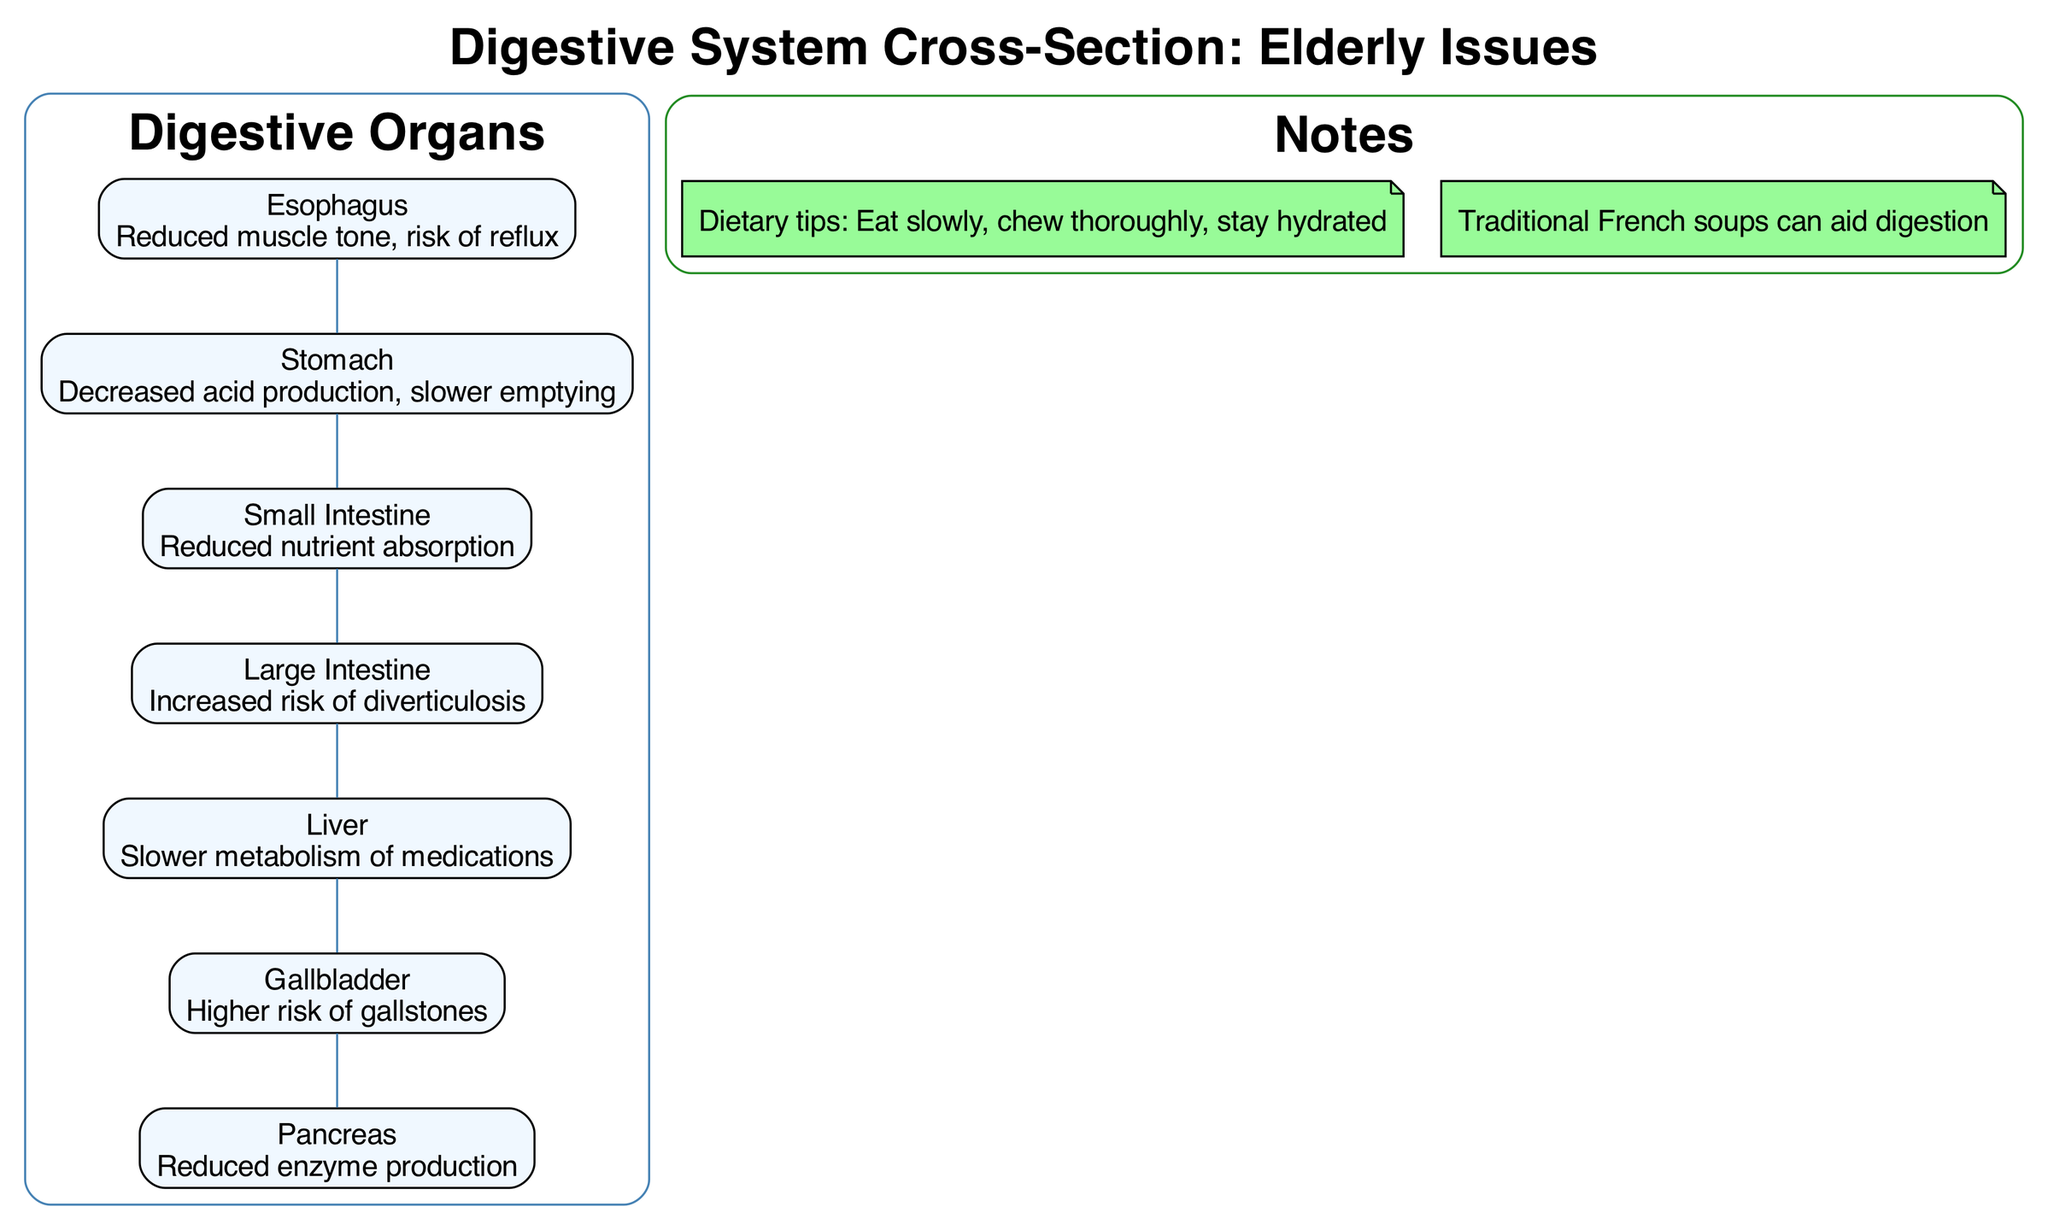What issue is associated with the esophagus? The diagram indicates that the esophagus has a problem with "Reduced muscle tone, risk of reflux." This information is directly labeled on the esophagus organ in the diagram.
Answer: Reduced muscle tone, risk of reflux How many organs are listed in the diagram? The diagram displays a total of seven organs labeled from esophagus to pancreas. This can be counted directly by looking at the organ nodes in the depicted digestive system.
Answer: 7 What issue affects the large intestine? According to the diagram, the large intestine is linked to "Increased risk of diverticulosis." This issue is noted specifically next to the large intestine in the diagram.
Answer: Increased risk of diverticulosis Which organ is associated with slower metabolism of medications? The liver is indicated to be associated with "Slower metabolism of medications" in the diagram. This detail is specified in the corresponding organ label for the liver.
Answer: Liver What dietary tip is given in the notes section? One of the notes suggests to "Eat slowly, chew thoroughly, stay hydrated." This dietary tip is provided specifically in the note section, indicating good practice for digestive health.
Answer: Eat slowly, chew thoroughly, stay hydrated What is the issue related to the pancreas? The pancreas has "Reduced enzyme production" noted as its associated issue in the diagram. This is explicitly labeled next to the pancreas in the digestive system cross-section.
Answer: Reduced enzyme production Which organ comes after the stomach in the digestive sequence? After the stomach, the next organ in the diagram is the small intestine. This can be determined by following the flow of the digestive organs as listed in the cross-section.
Answer: Small intestine What type of digestive issues are shown in this diagram? The diagram includes various issues such as reduced muscle tone, slower metabolism, and increased risk of certain conditions, collectively indicating common complications faced by the elderly in the digestive system.
Answer: Common complications in elderly digestion 